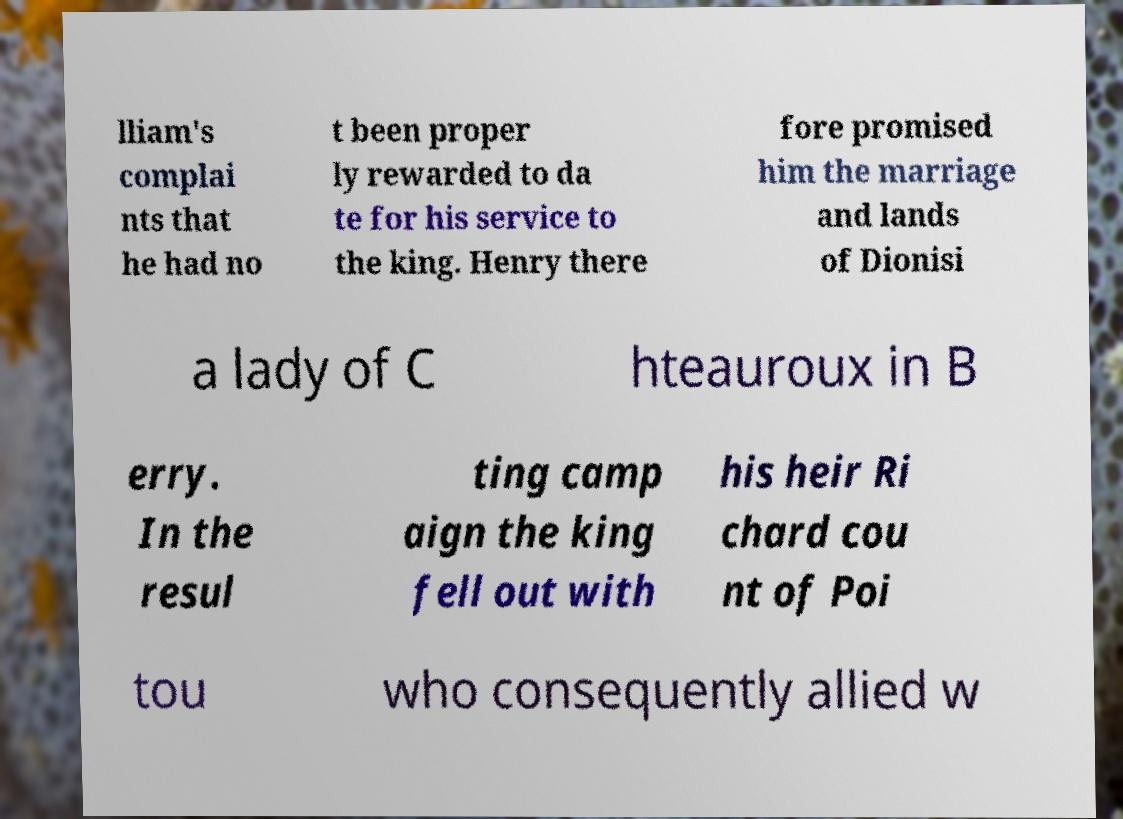I need the written content from this picture converted into text. Can you do that? lliam's complai nts that he had no t been proper ly rewarded to da te for his service to the king. Henry there fore promised him the marriage and lands of Dionisi a lady of C hteauroux in B erry. In the resul ting camp aign the king fell out with his heir Ri chard cou nt of Poi tou who consequently allied w 